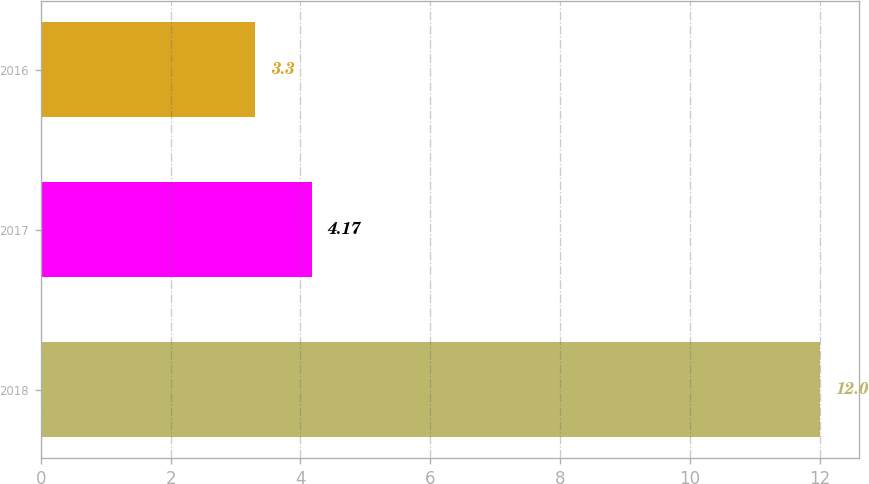Convert chart to OTSL. <chart><loc_0><loc_0><loc_500><loc_500><bar_chart><fcel>2018<fcel>2017<fcel>2016<nl><fcel>12<fcel>4.17<fcel>3.3<nl></chart> 